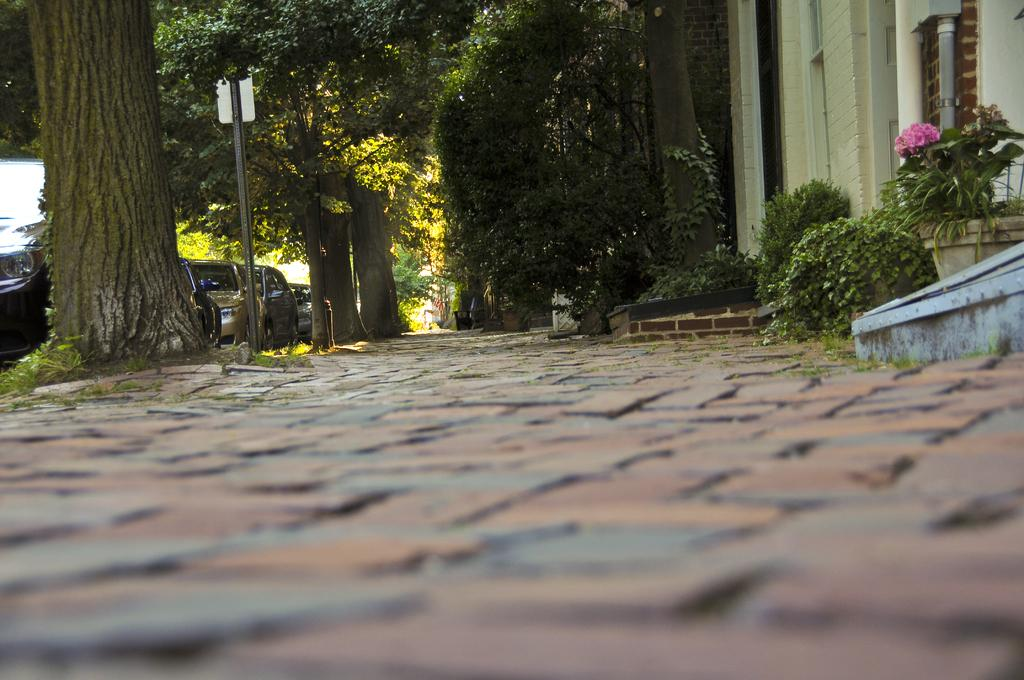What type of vegetation can be seen in the image? There are plants, flowers, and trees in the image. What else is present in the image besides vegetation? There are poles and vehicles in the image. What time of day is it in the image, and what company is hosting the event? The provided facts do not mention the time of day or any company hosting an event. The image only shows plants, flowers, trees, poles, and vehicles. 